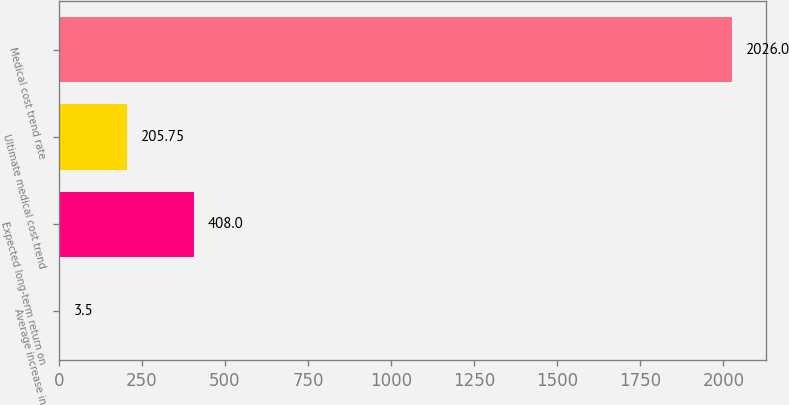Convert chart. <chart><loc_0><loc_0><loc_500><loc_500><bar_chart><fcel>Average increase in<fcel>Expected long-term return on<fcel>Ultimate medical cost trend<fcel>Medical cost trend rate<nl><fcel>3.5<fcel>408<fcel>205.75<fcel>2026<nl></chart> 